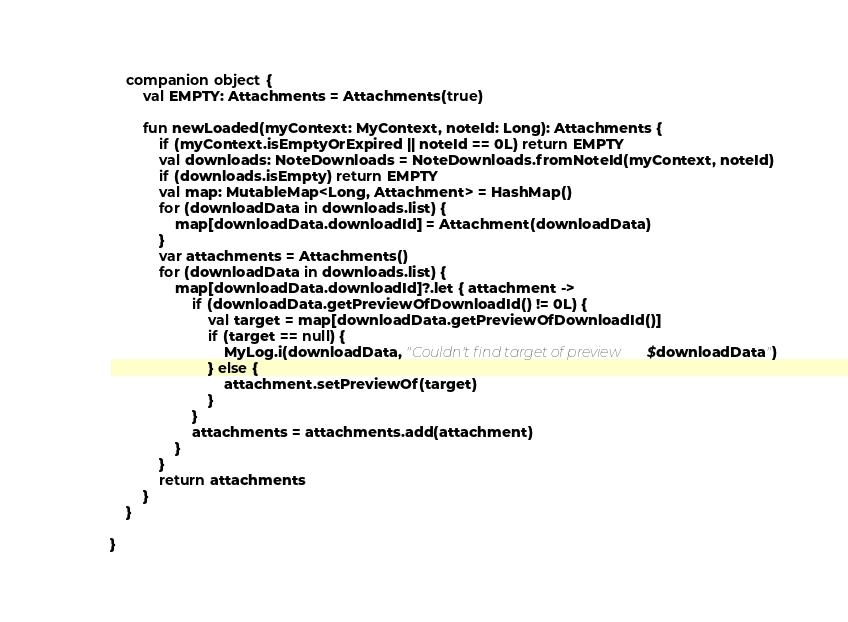Convert code to text. <code><loc_0><loc_0><loc_500><loc_500><_Kotlin_>    companion object {
        val EMPTY: Attachments = Attachments(true)

        fun newLoaded(myContext: MyContext, noteId: Long): Attachments {
            if (myContext.isEmptyOrExpired || noteId == 0L) return EMPTY
            val downloads: NoteDownloads = NoteDownloads.fromNoteId(myContext, noteId)
            if (downloads.isEmpty) return EMPTY
            val map: MutableMap<Long, Attachment> = HashMap()
            for (downloadData in downloads.list) {
                map[downloadData.downloadId] = Attachment(downloadData)
            }
            var attachments = Attachments()
            for (downloadData in downloads.list) {
                map[downloadData.downloadId]?.let { attachment ->
                    if (downloadData.getPreviewOfDownloadId() != 0L) {
                        val target = map[downloadData.getPreviewOfDownloadId()]
                        if (target == null) {
                            MyLog.i(downloadData, "Couldn't find target of preview $downloadData")
                        } else {
                            attachment.setPreviewOf(target)
                        }
                    }
                    attachments = attachments.add(attachment)
                }
            }
            return attachments
        }
    }

}
</code> 